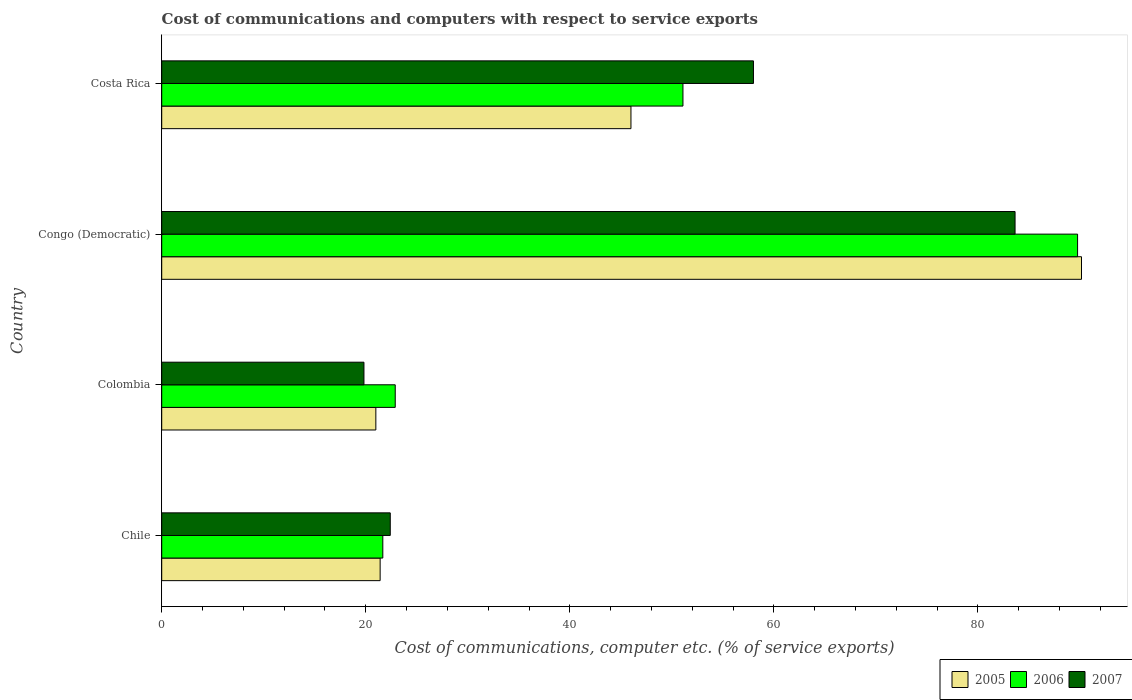Are the number of bars per tick equal to the number of legend labels?
Your response must be concise. Yes. How many bars are there on the 3rd tick from the bottom?
Keep it short and to the point. 3. What is the label of the 4th group of bars from the top?
Provide a succinct answer. Chile. In how many cases, is the number of bars for a given country not equal to the number of legend labels?
Provide a short and direct response. 0. What is the cost of communications and computers in 2006 in Congo (Democratic)?
Ensure brevity in your answer.  89.77. Across all countries, what is the maximum cost of communications and computers in 2007?
Make the answer very short. 83.64. Across all countries, what is the minimum cost of communications and computers in 2006?
Provide a succinct answer. 21.67. In which country was the cost of communications and computers in 2005 maximum?
Your response must be concise. Congo (Democratic). In which country was the cost of communications and computers in 2007 minimum?
Give a very brief answer. Colombia. What is the total cost of communications and computers in 2007 in the graph?
Keep it short and to the point. 183.86. What is the difference between the cost of communications and computers in 2007 in Colombia and that in Costa Rica?
Provide a short and direct response. -38.18. What is the difference between the cost of communications and computers in 2007 in Chile and the cost of communications and computers in 2006 in Costa Rica?
Your answer should be very brief. -28.69. What is the average cost of communications and computers in 2007 per country?
Offer a very short reply. 45.97. What is the difference between the cost of communications and computers in 2006 and cost of communications and computers in 2007 in Colombia?
Keep it short and to the point. 3.07. In how many countries, is the cost of communications and computers in 2006 greater than 64 %?
Provide a short and direct response. 1. What is the ratio of the cost of communications and computers in 2007 in Chile to that in Costa Rica?
Offer a terse response. 0.39. Is the cost of communications and computers in 2005 in Colombia less than that in Congo (Democratic)?
Provide a succinct answer. Yes. What is the difference between the highest and the second highest cost of communications and computers in 2007?
Your response must be concise. 25.64. What is the difference between the highest and the lowest cost of communications and computers in 2005?
Your answer should be compact. 69.16. In how many countries, is the cost of communications and computers in 2005 greater than the average cost of communications and computers in 2005 taken over all countries?
Keep it short and to the point. 2. Is the sum of the cost of communications and computers in 2005 in Colombia and Congo (Democratic) greater than the maximum cost of communications and computers in 2007 across all countries?
Your answer should be very brief. Yes. Are all the bars in the graph horizontal?
Ensure brevity in your answer.  Yes. How many countries are there in the graph?
Your response must be concise. 4. Does the graph contain any zero values?
Make the answer very short. No. How many legend labels are there?
Ensure brevity in your answer.  3. What is the title of the graph?
Your answer should be compact. Cost of communications and computers with respect to service exports. What is the label or title of the X-axis?
Your answer should be very brief. Cost of communications, computer etc. (% of service exports). What is the label or title of the Y-axis?
Your answer should be compact. Country. What is the Cost of communications, computer etc. (% of service exports) in 2005 in Chile?
Your answer should be very brief. 21.41. What is the Cost of communications, computer etc. (% of service exports) in 2006 in Chile?
Your answer should be very brief. 21.67. What is the Cost of communications, computer etc. (% of service exports) in 2007 in Chile?
Make the answer very short. 22.4. What is the Cost of communications, computer etc. (% of service exports) in 2005 in Colombia?
Keep it short and to the point. 20.99. What is the Cost of communications, computer etc. (% of service exports) of 2006 in Colombia?
Your answer should be very brief. 22.89. What is the Cost of communications, computer etc. (% of service exports) of 2007 in Colombia?
Your answer should be very brief. 19.82. What is the Cost of communications, computer etc. (% of service exports) in 2005 in Congo (Democratic)?
Give a very brief answer. 90.15. What is the Cost of communications, computer etc. (% of service exports) in 2006 in Congo (Democratic)?
Offer a terse response. 89.77. What is the Cost of communications, computer etc. (% of service exports) of 2007 in Congo (Democratic)?
Keep it short and to the point. 83.64. What is the Cost of communications, computer etc. (% of service exports) in 2005 in Costa Rica?
Give a very brief answer. 45.99. What is the Cost of communications, computer etc. (% of service exports) of 2006 in Costa Rica?
Keep it short and to the point. 51.09. What is the Cost of communications, computer etc. (% of service exports) in 2007 in Costa Rica?
Provide a succinct answer. 58. Across all countries, what is the maximum Cost of communications, computer etc. (% of service exports) of 2005?
Provide a short and direct response. 90.15. Across all countries, what is the maximum Cost of communications, computer etc. (% of service exports) in 2006?
Your answer should be very brief. 89.77. Across all countries, what is the maximum Cost of communications, computer etc. (% of service exports) of 2007?
Ensure brevity in your answer.  83.64. Across all countries, what is the minimum Cost of communications, computer etc. (% of service exports) in 2005?
Your response must be concise. 20.99. Across all countries, what is the minimum Cost of communications, computer etc. (% of service exports) in 2006?
Offer a very short reply. 21.67. Across all countries, what is the minimum Cost of communications, computer etc. (% of service exports) of 2007?
Your answer should be very brief. 19.82. What is the total Cost of communications, computer etc. (% of service exports) in 2005 in the graph?
Provide a succinct answer. 178.54. What is the total Cost of communications, computer etc. (% of service exports) of 2006 in the graph?
Your response must be concise. 185.42. What is the total Cost of communications, computer etc. (% of service exports) of 2007 in the graph?
Keep it short and to the point. 183.86. What is the difference between the Cost of communications, computer etc. (% of service exports) of 2005 in Chile and that in Colombia?
Offer a terse response. 0.42. What is the difference between the Cost of communications, computer etc. (% of service exports) of 2006 in Chile and that in Colombia?
Give a very brief answer. -1.22. What is the difference between the Cost of communications, computer etc. (% of service exports) of 2007 in Chile and that in Colombia?
Offer a terse response. 2.58. What is the difference between the Cost of communications, computer etc. (% of service exports) in 2005 in Chile and that in Congo (Democratic)?
Your response must be concise. -68.74. What is the difference between the Cost of communications, computer etc. (% of service exports) of 2006 in Chile and that in Congo (Democratic)?
Offer a very short reply. -68.1. What is the difference between the Cost of communications, computer etc. (% of service exports) in 2007 in Chile and that in Congo (Democratic)?
Your response must be concise. -61.24. What is the difference between the Cost of communications, computer etc. (% of service exports) of 2005 in Chile and that in Costa Rica?
Your answer should be very brief. -24.58. What is the difference between the Cost of communications, computer etc. (% of service exports) of 2006 in Chile and that in Costa Rica?
Ensure brevity in your answer.  -29.42. What is the difference between the Cost of communications, computer etc. (% of service exports) of 2007 in Chile and that in Costa Rica?
Your answer should be very brief. -35.6. What is the difference between the Cost of communications, computer etc. (% of service exports) of 2005 in Colombia and that in Congo (Democratic)?
Provide a succinct answer. -69.16. What is the difference between the Cost of communications, computer etc. (% of service exports) of 2006 in Colombia and that in Congo (Democratic)?
Make the answer very short. -66.88. What is the difference between the Cost of communications, computer etc. (% of service exports) of 2007 in Colombia and that in Congo (Democratic)?
Offer a very short reply. -63.82. What is the difference between the Cost of communications, computer etc. (% of service exports) in 2005 in Colombia and that in Costa Rica?
Ensure brevity in your answer.  -25. What is the difference between the Cost of communications, computer etc. (% of service exports) in 2006 in Colombia and that in Costa Rica?
Provide a succinct answer. -28.2. What is the difference between the Cost of communications, computer etc. (% of service exports) in 2007 in Colombia and that in Costa Rica?
Your answer should be compact. -38.18. What is the difference between the Cost of communications, computer etc. (% of service exports) of 2005 in Congo (Democratic) and that in Costa Rica?
Ensure brevity in your answer.  44.16. What is the difference between the Cost of communications, computer etc. (% of service exports) of 2006 in Congo (Democratic) and that in Costa Rica?
Keep it short and to the point. 38.68. What is the difference between the Cost of communications, computer etc. (% of service exports) in 2007 in Congo (Democratic) and that in Costa Rica?
Your answer should be compact. 25.64. What is the difference between the Cost of communications, computer etc. (% of service exports) in 2005 in Chile and the Cost of communications, computer etc. (% of service exports) in 2006 in Colombia?
Offer a very short reply. -1.48. What is the difference between the Cost of communications, computer etc. (% of service exports) in 2005 in Chile and the Cost of communications, computer etc. (% of service exports) in 2007 in Colombia?
Provide a short and direct response. 1.59. What is the difference between the Cost of communications, computer etc. (% of service exports) in 2006 in Chile and the Cost of communications, computer etc. (% of service exports) in 2007 in Colombia?
Offer a terse response. 1.85. What is the difference between the Cost of communications, computer etc. (% of service exports) in 2005 in Chile and the Cost of communications, computer etc. (% of service exports) in 2006 in Congo (Democratic)?
Offer a very short reply. -68.36. What is the difference between the Cost of communications, computer etc. (% of service exports) in 2005 in Chile and the Cost of communications, computer etc. (% of service exports) in 2007 in Congo (Democratic)?
Ensure brevity in your answer.  -62.23. What is the difference between the Cost of communications, computer etc. (% of service exports) in 2006 in Chile and the Cost of communications, computer etc. (% of service exports) in 2007 in Congo (Democratic)?
Keep it short and to the point. -61.97. What is the difference between the Cost of communications, computer etc. (% of service exports) of 2005 in Chile and the Cost of communications, computer etc. (% of service exports) of 2006 in Costa Rica?
Make the answer very short. -29.68. What is the difference between the Cost of communications, computer etc. (% of service exports) of 2005 in Chile and the Cost of communications, computer etc. (% of service exports) of 2007 in Costa Rica?
Offer a terse response. -36.59. What is the difference between the Cost of communications, computer etc. (% of service exports) in 2006 in Chile and the Cost of communications, computer etc. (% of service exports) in 2007 in Costa Rica?
Make the answer very short. -36.33. What is the difference between the Cost of communications, computer etc. (% of service exports) of 2005 in Colombia and the Cost of communications, computer etc. (% of service exports) of 2006 in Congo (Democratic)?
Provide a succinct answer. -68.78. What is the difference between the Cost of communications, computer etc. (% of service exports) of 2005 in Colombia and the Cost of communications, computer etc. (% of service exports) of 2007 in Congo (Democratic)?
Your answer should be compact. -62.65. What is the difference between the Cost of communications, computer etc. (% of service exports) in 2006 in Colombia and the Cost of communications, computer etc. (% of service exports) in 2007 in Congo (Democratic)?
Provide a succinct answer. -60.75. What is the difference between the Cost of communications, computer etc. (% of service exports) of 2005 in Colombia and the Cost of communications, computer etc. (% of service exports) of 2006 in Costa Rica?
Ensure brevity in your answer.  -30.1. What is the difference between the Cost of communications, computer etc. (% of service exports) of 2005 in Colombia and the Cost of communications, computer etc. (% of service exports) of 2007 in Costa Rica?
Keep it short and to the point. -37.01. What is the difference between the Cost of communications, computer etc. (% of service exports) of 2006 in Colombia and the Cost of communications, computer etc. (% of service exports) of 2007 in Costa Rica?
Your answer should be very brief. -35.11. What is the difference between the Cost of communications, computer etc. (% of service exports) in 2005 in Congo (Democratic) and the Cost of communications, computer etc. (% of service exports) in 2006 in Costa Rica?
Your answer should be very brief. 39.06. What is the difference between the Cost of communications, computer etc. (% of service exports) in 2005 in Congo (Democratic) and the Cost of communications, computer etc. (% of service exports) in 2007 in Costa Rica?
Offer a terse response. 32.15. What is the difference between the Cost of communications, computer etc. (% of service exports) of 2006 in Congo (Democratic) and the Cost of communications, computer etc. (% of service exports) of 2007 in Costa Rica?
Offer a terse response. 31.77. What is the average Cost of communications, computer etc. (% of service exports) of 2005 per country?
Your response must be concise. 44.64. What is the average Cost of communications, computer etc. (% of service exports) of 2006 per country?
Offer a very short reply. 46.35. What is the average Cost of communications, computer etc. (% of service exports) in 2007 per country?
Ensure brevity in your answer.  45.97. What is the difference between the Cost of communications, computer etc. (% of service exports) in 2005 and Cost of communications, computer etc. (% of service exports) in 2006 in Chile?
Keep it short and to the point. -0.26. What is the difference between the Cost of communications, computer etc. (% of service exports) of 2005 and Cost of communications, computer etc. (% of service exports) of 2007 in Chile?
Provide a succinct answer. -0.99. What is the difference between the Cost of communications, computer etc. (% of service exports) in 2006 and Cost of communications, computer etc. (% of service exports) in 2007 in Chile?
Ensure brevity in your answer.  -0.73. What is the difference between the Cost of communications, computer etc. (% of service exports) of 2005 and Cost of communications, computer etc. (% of service exports) of 2006 in Colombia?
Provide a short and direct response. -1.9. What is the difference between the Cost of communications, computer etc. (% of service exports) in 2005 and Cost of communications, computer etc. (% of service exports) in 2007 in Colombia?
Make the answer very short. 1.17. What is the difference between the Cost of communications, computer etc. (% of service exports) of 2006 and Cost of communications, computer etc. (% of service exports) of 2007 in Colombia?
Give a very brief answer. 3.07. What is the difference between the Cost of communications, computer etc. (% of service exports) in 2005 and Cost of communications, computer etc. (% of service exports) in 2006 in Congo (Democratic)?
Provide a short and direct response. 0.38. What is the difference between the Cost of communications, computer etc. (% of service exports) of 2005 and Cost of communications, computer etc. (% of service exports) of 2007 in Congo (Democratic)?
Your response must be concise. 6.51. What is the difference between the Cost of communications, computer etc. (% of service exports) in 2006 and Cost of communications, computer etc. (% of service exports) in 2007 in Congo (Democratic)?
Your response must be concise. 6.13. What is the difference between the Cost of communications, computer etc. (% of service exports) of 2005 and Cost of communications, computer etc. (% of service exports) of 2006 in Costa Rica?
Offer a very short reply. -5.1. What is the difference between the Cost of communications, computer etc. (% of service exports) of 2005 and Cost of communications, computer etc. (% of service exports) of 2007 in Costa Rica?
Provide a succinct answer. -12.01. What is the difference between the Cost of communications, computer etc. (% of service exports) in 2006 and Cost of communications, computer etc. (% of service exports) in 2007 in Costa Rica?
Give a very brief answer. -6.91. What is the ratio of the Cost of communications, computer etc. (% of service exports) of 2005 in Chile to that in Colombia?
Make the answer very short. 1.02. What is the ratio of the Cost of communications, computer etc. (% of service exports) in 2006 in Chile to that in Colombia?
Offer a very short reply. 0.95. What is the ratio of the Cost of communications, computer etc. (% of service exports) of 2007 in Chile to that in Colombia?
Make the answer very short. 1.13. What is the ratio of the Cost of communications, computer etc. (% of service exports) in 2005 in Chile to that in Congo (Democratic)?
Your response must be concise. 0.24. What is the ratio of the Cost of communications, computer etc. (% of service exports) of 2006 in Chile to that in Congo (Democratic)?
Offer a terse response. 0.24. What is the ratio of the Cost of communications, computer etc. (% of service exports) in 2007 in Chile to that in Congo (Democratic)?
Give a very brief answer. 0.27. What is the ratio of the Cost of communications, computer etc. (% of service exports) of 2005 in Chile to that in Costa Rica?
Provide a succinct answer. 0.47. What is the ratio of the Cost of communications, computer etc. (% of service exports) of 2006 in Chile to that in Costa Rica?
Your response must be concise. 0.42. What is the ratio of the Cost of communications, computer etc. (% of service exports) in 2007 in Chile to that in Costa Rica?
Ensure brevity in your answer.  0.39. What is the ratio of the Cost of communications, computer etc. (% of service exports) of 2005 in Colombia to that in Congo (Democratic)?
Keep it short and to the point. 0.23. What is the ratio of the Cost of communications, computer etc. (% of service exports) of 2006 in Colombia to that in Congo (Democratic)?
Give a very brief answer. 0.26. What is the ratio of the Cost of communications, computer etc. (% of service exports) of 2007 in Colombia to that in Congo (Democratic)?
Your answer should be very brief. 0.24. What is the ratio of the Cost of communications, computer etc. (% of service exports) in 2005 in Colombia to that in Costa Rica?
Ensure brevity in your answer.  0.46. What is the ratio of the Cost of communications, computer etc. (% of service exports) in 2006 in Colombia to that in Costa Rica?
Your answer should be very brief. 0.45. What is the ratio of the Cost of communications, computer etc. (% of service exports) in 2007 in Colombia to that in Costa Rica?
Your answer should be very brief. 0.34. What is the ratio of the Cost of communications, computer etc. (% of service exports) of 2005 in Congo (Democratic) to that in Costa Rica?
Make the answer very short. 1.96. What is the ratio of the Cost of communications, computer etc. (% of service exports) in 2006 in Congo (Democratic) to that in Costa Rica?
Your answer should be very brief. 1.76. What is the ratio of the Cost of communications, computer etc. (% of service exports) in 2007 in Congo (Democratic) to that in Costa Rica?
Provide a short and direct response. 1.44. What is the difference between the highest and the second highest Cost of communications, computer etc. (% of service exports) in 2005?
Keep it short and to the point. 44.16. What is the difference between the highest and the second highest Cost of communications, computer etc. (% of service exports) of 2006?
Your answer should be very brief. 38.68. What is the difference between the highest and the second highest Cost of communications, computer etc. (% of service exports) in 2007?
Keep it short and to the point. 25.64. What is the difference between the highest and the lowest Cost of communications, computer etc. (% of service exports) in 2005?
Offer a very short reply. 69.16. What is the difference between the highest and the lowest Cost of communications, computer etc. (% of service exports) of 2006?
Offer a terse response. 68.1. What is the difference between the highest and the lowest Cost of communications, computer etc. (% of service exports) in 2007?
Your answer should be compact. 63.82. 